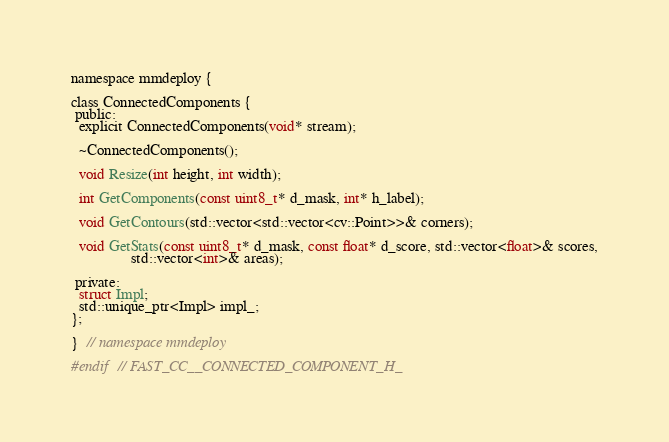Convert code to text. <code><loc_0><loc_0><loc_500><loc_500><_C_>
namespace mmdeploy {

class ConnectedComponents {
 public:
  explicit ConnectedComponents(void* stream);

  ~ConnectedComponents();

  void Resize(int height, int width);

  int GetComponents(const uint8_t* d_mask, int* h_label);

  void GetContours(std::vector<std::vector<cv::Point>>& corners);

  void GetStats(const uint8_t* d_mask, const float* d_score, std::vector<float>& scores,
                std::vector<int>& areas);

 private:
  struct Impl;
  std::unique_ptr<Impl> impl_;
};

}  // namespace mmdeploy

#endif  // FAST_CC__CONNECTED_COMPONENT_H_
</code> 